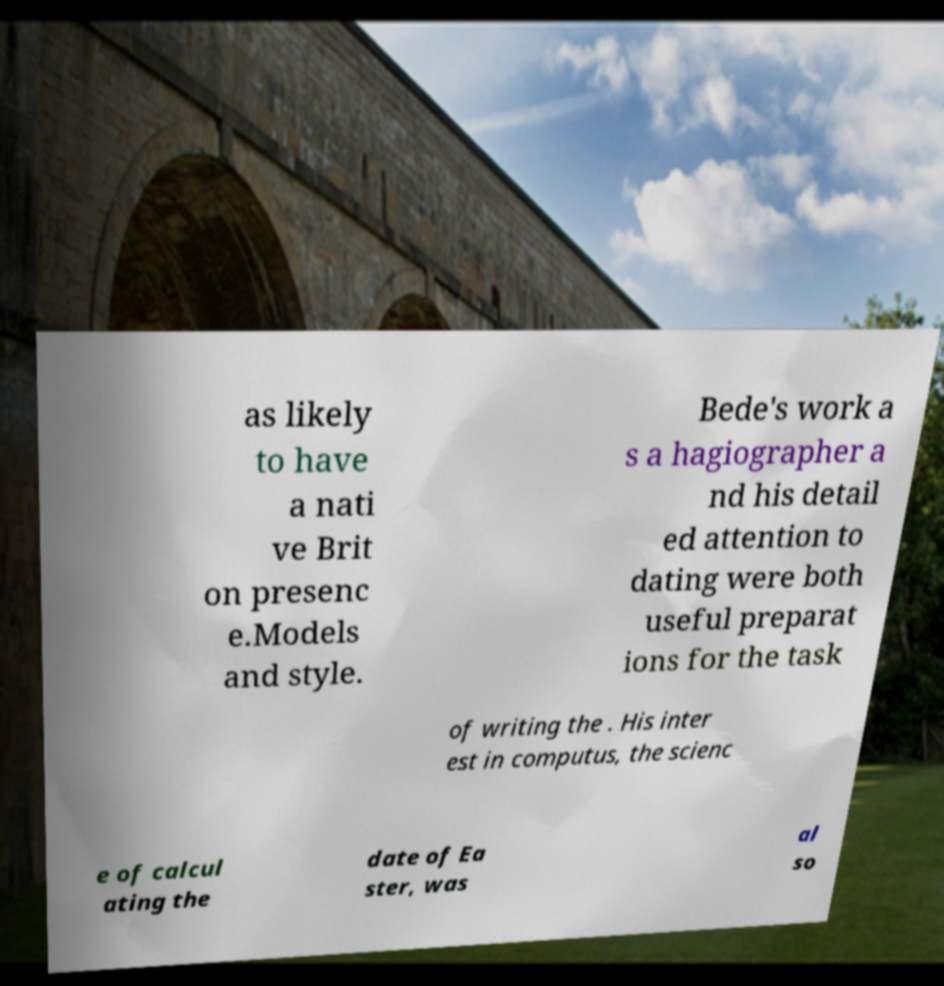Please read and relay the text visible in this image. What does it say? as likely to have a nati ve Brit on presenc e.Models and style. Bede's work a s a hagiographer a nd his detail ed attention to dating were both useful preparat ions for the task of writing the . His inter est in computus, the scienc e of calcul ating the date of Ea ster, was al so 